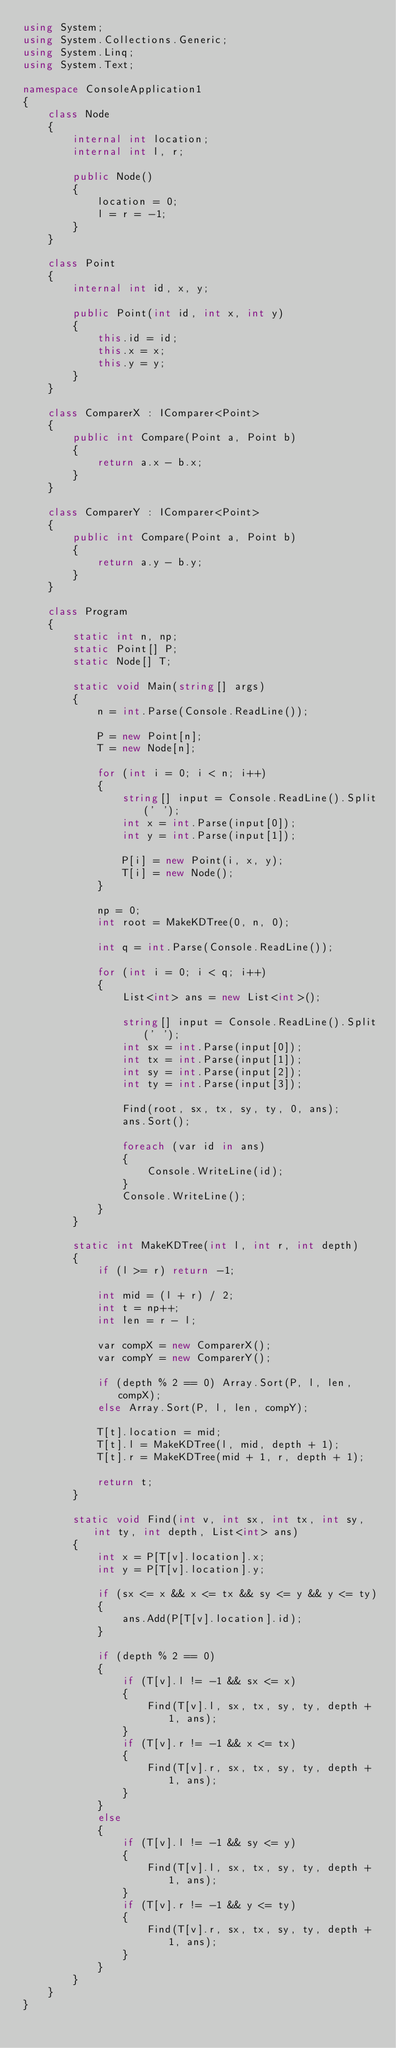Convert code to text. <code><loc_0><loc_0><loc_500><loc_500><_C#_>using System;
using System.Collections.Generic;
using System.Linq;
using System.Text;

namespace ConsoleApplication1
{
    class Node
    {
        internal int location;
        internal int l, r;

        public Node()
        {
            location = 0;
            l = r = -1;
        }
    }

    class Point
    {
        internal int id, x, y;

        public Point(int id, int x, int y)
        {
            this.id = id;
            this.x = x;
            this.y = y;
        }
    }

    class ComparerX : IComparer<Point>
    {
        public int Compare(Point a, Point b)
        {
            return a.x - b.x;
        }
    }

    class ComparerY : IComparer<Point>
    {
        public int Compare(Point a, Point b)
        {
            return a.y - b.y;
        }
    }

    class Program
    {
        static int n, np;
        static Point[] P;
        static Node[] T;

        static void Main(string[] args)
        {
            n = int.Parse(Console.ReadLine());

            P = new Point[n];
            T = new Node[n];

            for (int i = 0; i < n; i++)
            {
                string[] input = Console.ReadLine().Split(' ');
                int x = int.Parse(input[0]);
                int y = int.Parse(input[1]);

                P[i] = new Point(i, x, y);
                T[i] = new Node();
            }

            np = 0;
            int root = MakeKDTree(0, n, 0);

            int q = int.Parse(Console.ReadLine());

            for (int i = 0; i < q; i++)
            {
                List<int> ans = new List<int>();

                string[] input = Console.ReadLine().Split(' ');
                int sx = int.Parse(input[0]);
                int tx = int.Parse(input[1]);
                int sy = int.Parse(input[2]);
                int ty = int.Parse(input[3]);

                Find(root, sx, tx, sy, ty, 0, ans);
                ans.Sort();

                foreach (var id in ans)
                {
                    Console.WriteLine(id);
                }
                Console.WriteLine();
            }
        }

        static int MakeKDTree(int l, int r, int depth)
        {
            if (l >= r) return -1;

            int mid = (l + r) / 2;
            int t = np++;
            int len = r - l;
            
            var compX = new ComparerX();
            var compY = new ComparerY();

            if (depth % 2 == 0) Array.Sort(P, l, len, compX);
            else Array.Sort(P, l, len, compY);

            T[t].location = mid;
            T[t].l = MakeKDTree(l, mid, depth + 1);
            T[t].r = MakeKDTree(mid + 1, r, depth + 1);

            return t;
        }

        static void Find(int v, int sx, int tx, int sy, int ty, int depth, List<int> ans)
        {
            int x = P[T[v].location].x;
            int y = P[T[v].location].y;

            if (sx <= x && x <= tx && sy <= y && y <= ty)
            {
                ans.Add(P[T[v].location].id);
            }

            if (depth % 2 == 0)
            {
                if (T[v].l != -1 && sx <= x)
                {
                    Find(T[v].l, sx, tx, sy, ty, depth + 1, ans);
                }
                if (T[v].r != -1 && x <= tx)
                {
                    Find(T[v].r, sx, tx, sy, ty, depth + 1, ans);
                }
            }
            else
            {
                if (T[v].l != -1 && sy <= y)
                {
                    Find(T[v].l, sx, tx, sy, ty, depth + 1, ans);
                }
                if (T[v].r != -1 && y <= ty)
                {
                    Find(T[v].r, sx, tx, sy, ty, depth + 1, ans);
                }
            }
        }
    }
}</code> 